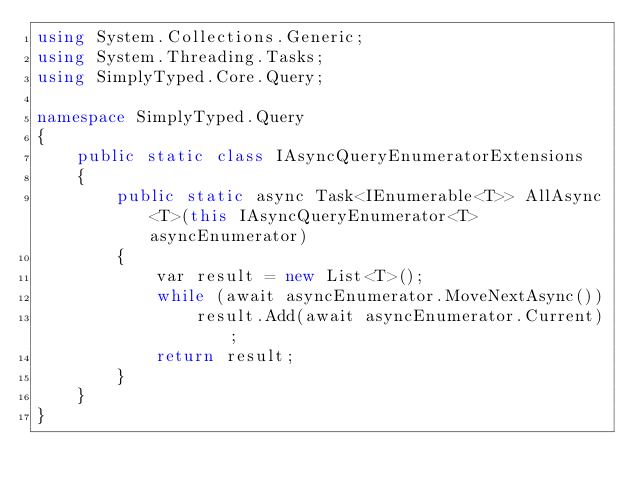<code> <loc_0><loc_0><loc_500><loc_500><_C#_>using System.Collections.Generic;
using System.Threading.Tasks;
using SimplyTyped.Core.Query;

namespace SimplyTyped.Query
{
    public static class IAsyncQueryEnumeratorExtensions
    {
        public static async Task<IEnumerable<T>> AllAsync<T>(this IAsyncQueryEnumerator<T> asyncEnumerator)
        {
            var result = new List<T>();
            while (await asyncEnumerator.MoveNextAsync())
                result.Add(await asyncEnumerator.Current);
            return result;
        }
    }
}</code> 